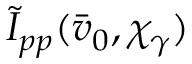<formula> <loc_0><loc_0><loc_500><loc_500>\tilde { I } _ { p p } ( \bar { v } _ { 0 } , \chi _ { \gamma } )</formula> 